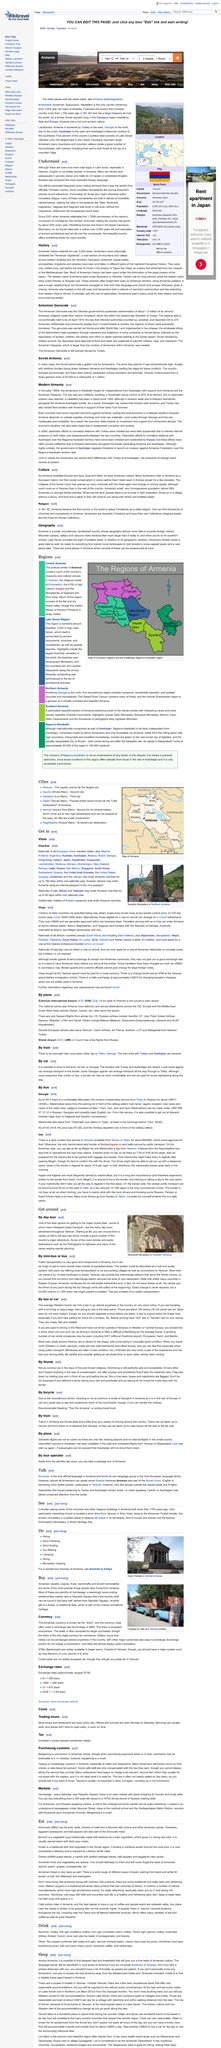List a handful of essential elements in this visual. The day tours are prominently advertised throughout Yerevan, making it easy for travelers to find and plan their itineraries. There are a number of remote and exotic destinations, such as the petroglyphs of Ughtasar and the caves, that offer unique and unforgettable experiences. The starting price for half to full day trips according to the article "Get around" is $6. 